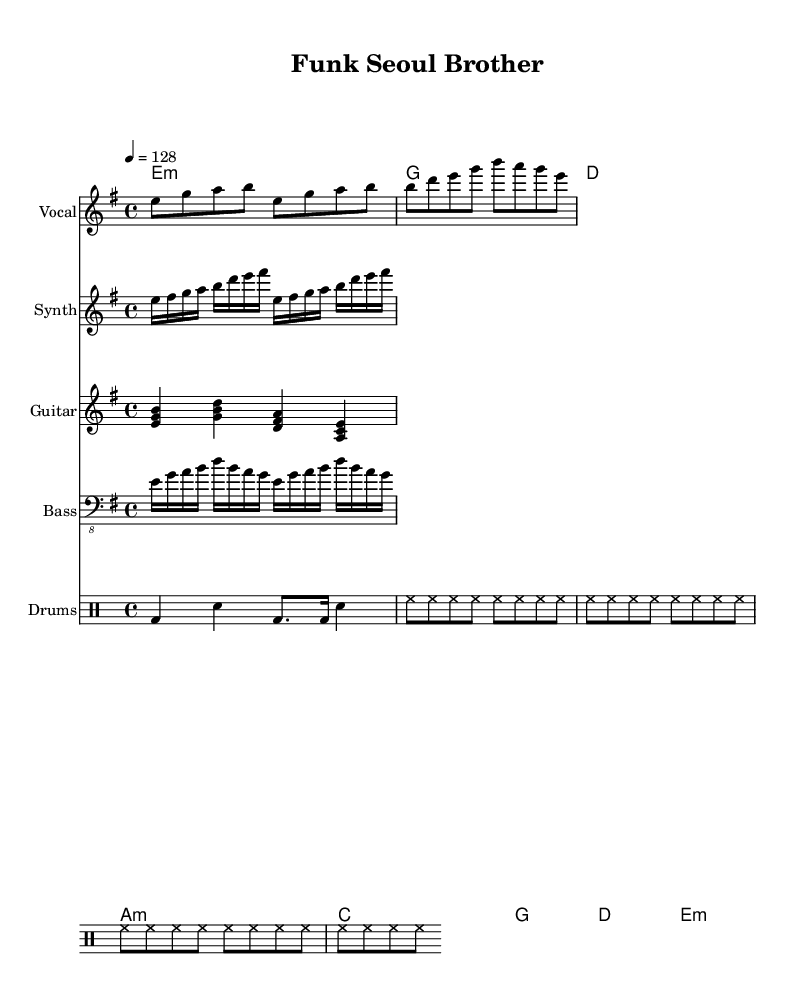What is the key signature of this music? The key signature is based on the first part of the global variable, and it shows the key of E minor, which is indicated by one sharp (F#).
Answer: E minor What is the time signature of this music? The time signature is presented in the global variable as 4/4, which is commonly used and indicates four beats in each measure.
Answer: 4/4 What is the tempo marking for this piece? The tempo marking is indicated as "4 = 128", meaning there are 128 beats per minute, a typical marking found in the global variable.
Answer: 128 How many measures are in the vocal melody? The vocal melody is composed of 16 beats, divided by the 8th notes in the song, resulting in two measures of 4/4 time.
Answer: 2 What type of instruments are featured in this piece? The instruments are specified throughout different staffs in the score, namely Vocal, Synth, Guitar, Bass, and Drums.
Answer: Vocal, Synth, Guitar, Bass, Drums What is the rhythmic pattern used in the drum section? Analyzing the drum pattern shows a combination of bass drum (bd), snare (sn), and hi-hat (hh) with patterns of quarter and eighth notes, indicative of a driving K-pop rhythm.
Answer: Bass, snare, hi-hat Which musical feature is reminiscent of RHCP in this piece? The use of slap bass and guitar riffs prominently throughout the score emulates the energetic style associated with RHCP, signifying the influence on the K-pop track.
Answer: Slap bass, guitar riffs 